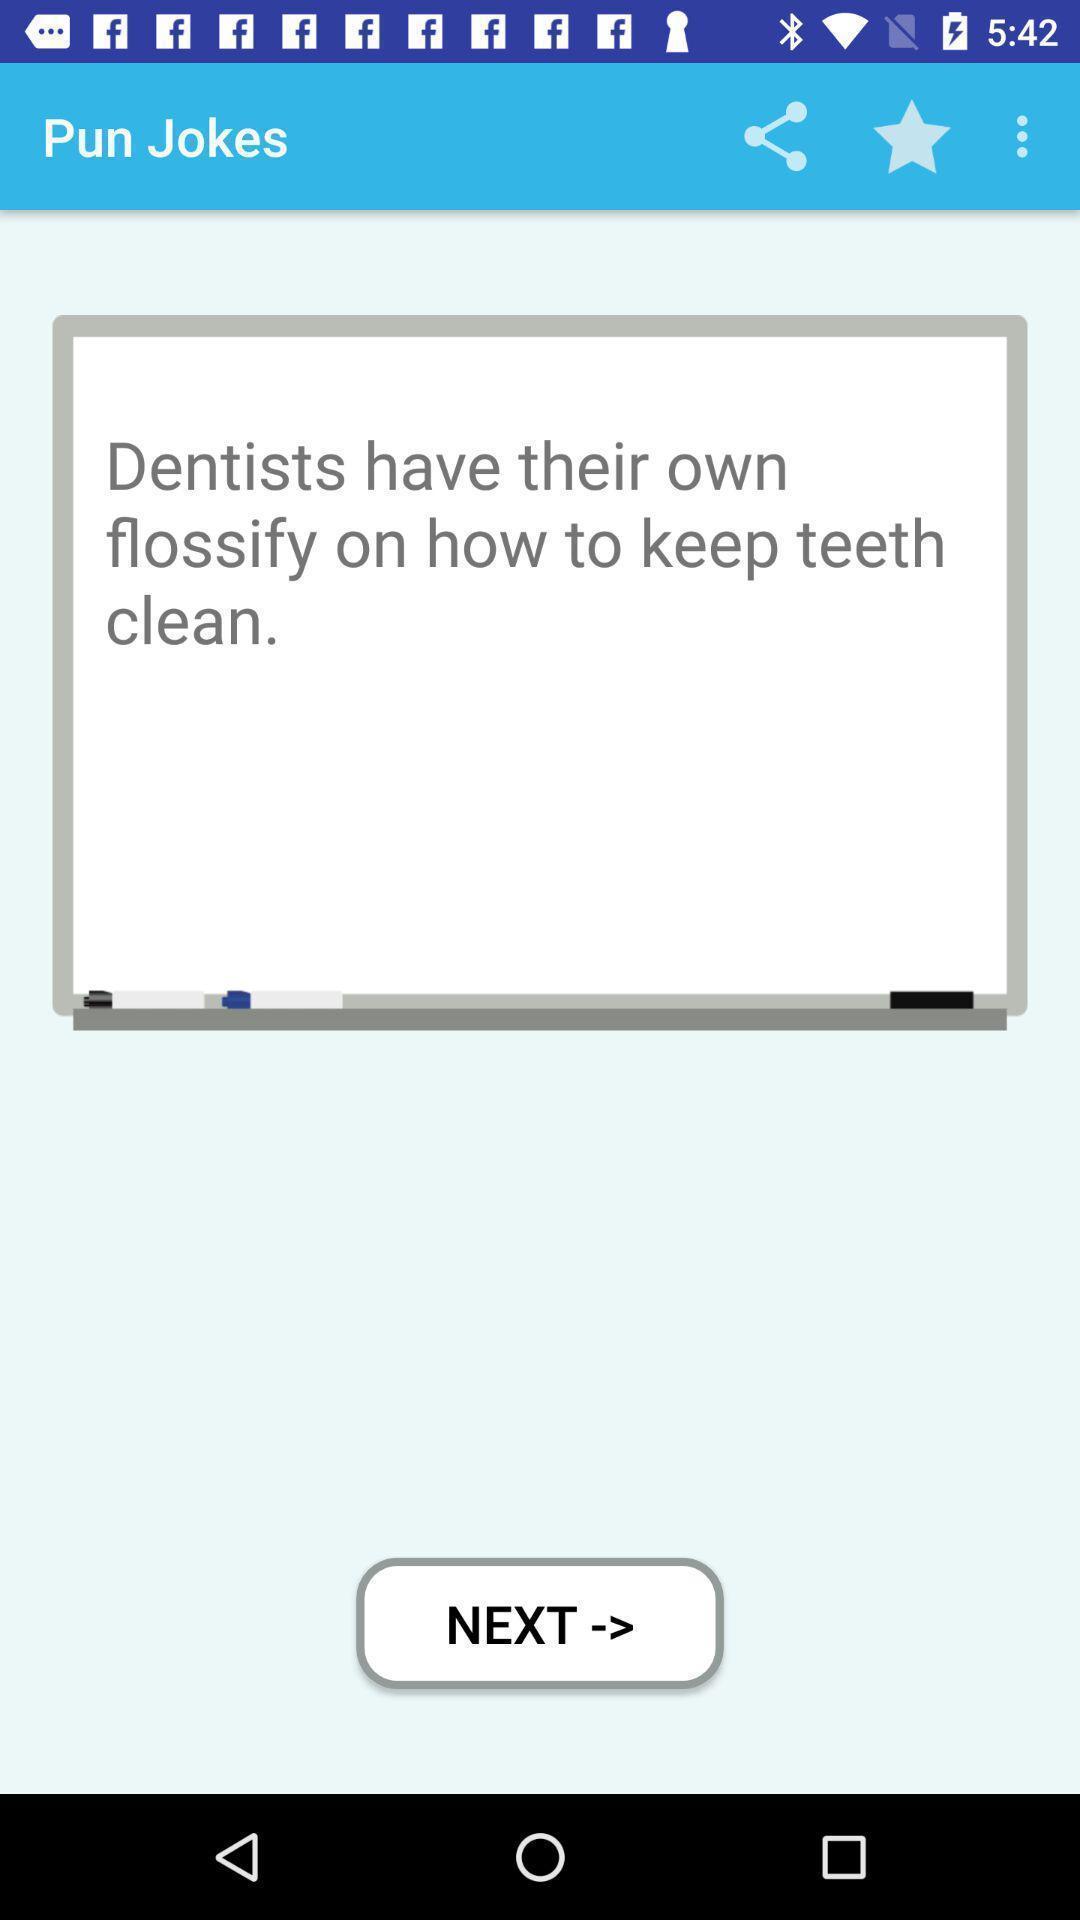Provide a description of this screenshot. Window displaying a jokes page app. 